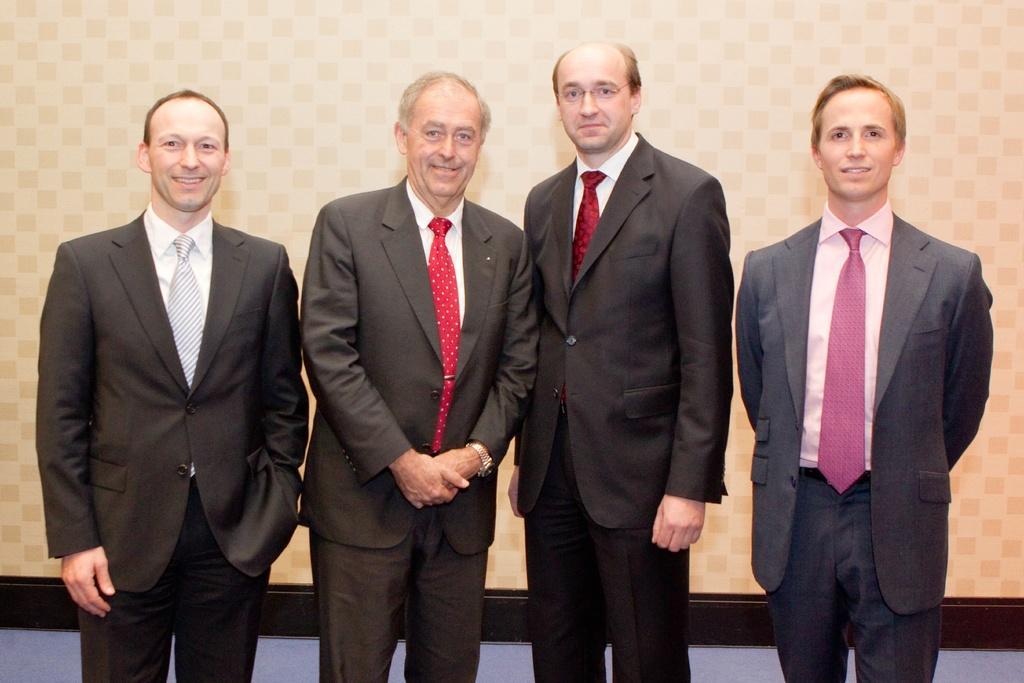Describe this image in one or two sentences. In the center of the image we can see men standing on the floor. In the background there is wall. 